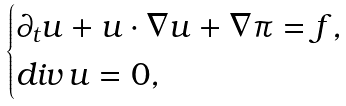<formula> <loc_0><loc_0><loc_500><loc_500>\begin{cases} \partial _ { t } \boldsymbol u + \boldsymbol u \cdot \nabla \boldsymbol u + \nabla \pi = \boldsymbol f , \\ { d i v \, } \boldsymbol u = 0 , \\ \end{cases}</formula> 